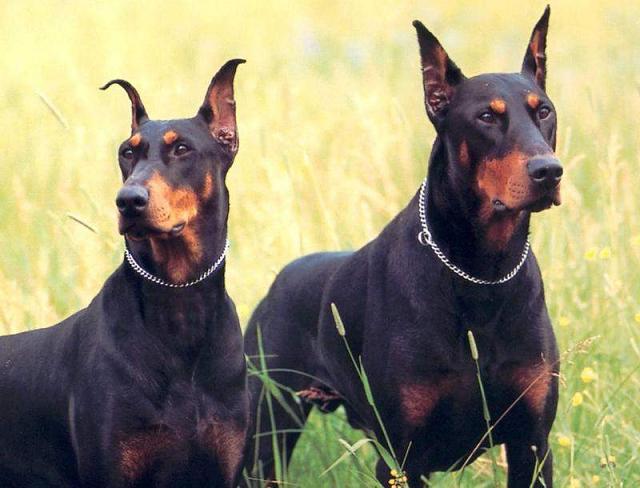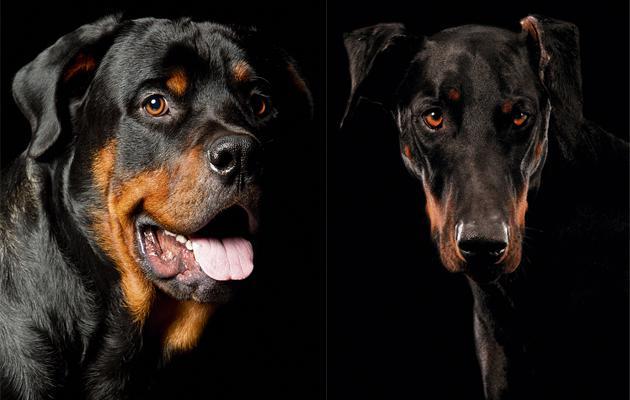The first image is the image on the left, the second image is the image on the right. Evaluate the accuracy of this statement regarding the images: "There is one dog without a collar". Is it true? Answer yes or no. No. 